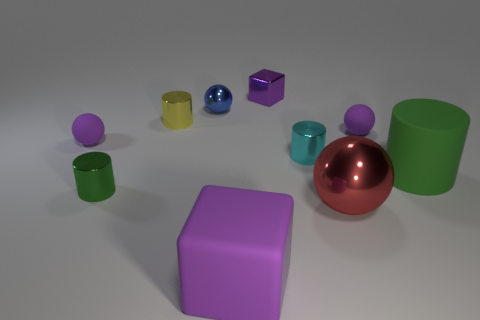Subtract all spheres. How many objects are left? 6 Add 5 large red rubber balls. How many large red rubber balls exist? 5 Subtract 0 cyan cubes. How many objects are left? 10 Subtract all metallic balls. Subtract all green metallic cylinders. How many objects are left? 7 Add 4 rubber cylinders. How many rubber cylinders are left? 5 